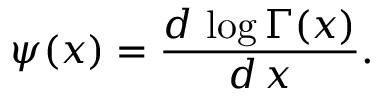<formula> <loc_0><loc_0><loc_500><loc_500>\psi ( x ) = \frac { d \, \log \Gamma ( x ) } { d \, x } .</formula> 